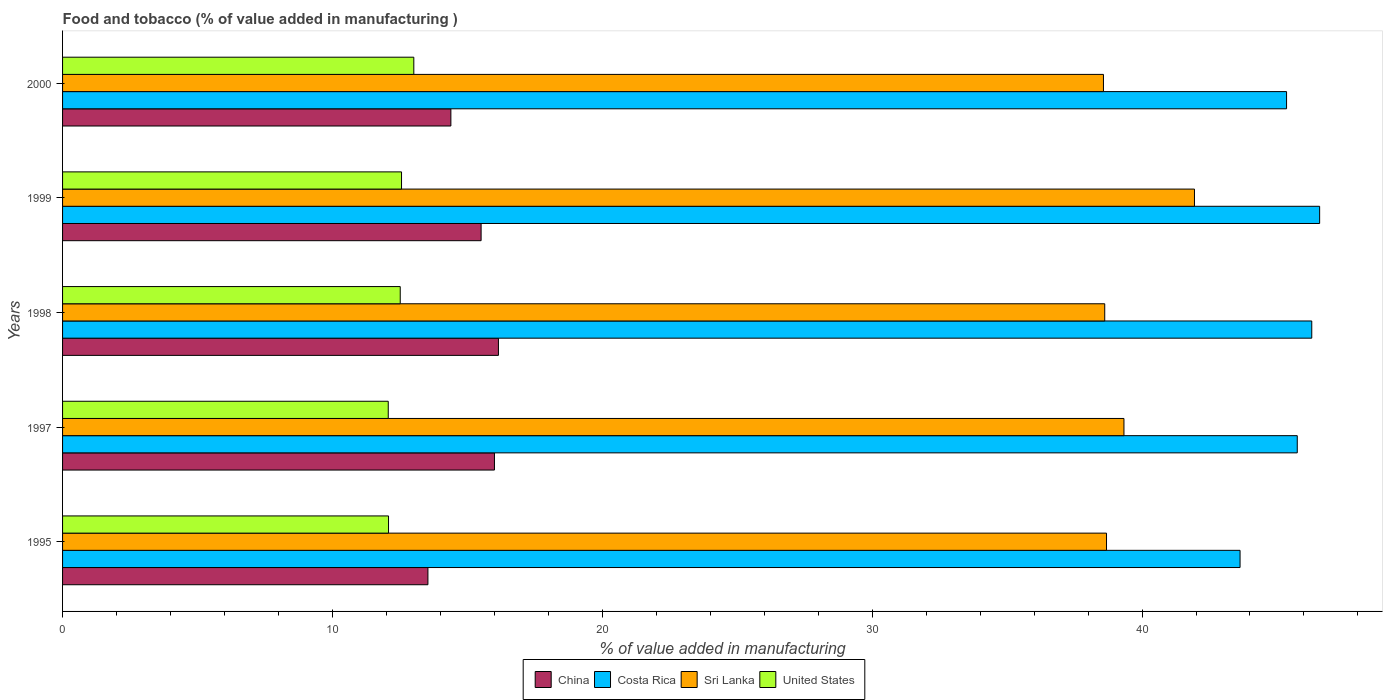How many different coloured bars are there?
Provide a short and direct response. 4. How many groups of bars are there?
Make the answer very short. 5. Are the number of bars on each tick of the Y-axis equal?
Ensure brevity in your answer.  Yes. How many bars are there on the 3rd tick from the bottom?
Offer a very short reply. 4. What is the label of the 2nd group of bars from the top?
Your response must be concise. 1999. What is the value added in manufacturing food and tobacco in Sri Lanka in 1995?
Offer a very short reply. 38.68. Across all years, what is the maximum value added in manufacturing food and tobacco in Sri Lanka?
Give a very brief answer. 41.94. Across all years, what is the minimum value added in manufacturing food and tobacco in Costa Rica?
Your answer should be compact. 43.63. In which year was the value added in manufacturing food and tobacco in Sri Lanka minimum?
Your response must be concise. 2000. What is the total value added in manufacturing food and tobacco in Sri Lanka in the graph?
Your response must be concise. 197.15. What is the difference between the value added in manufacturing food and tobacco in United States in 1998 and that in 1999?
Provide a succinct answer. -0.05. What is the difference between the value added in manufacturing food and tobacco in China in 1997 and the value added in manufacturing food and tobacco in United States in 1998?
Offer a very short reply. 3.49. What is the average value added in manufacturing food and tobacco in Sri Lanka per year?
Offer a terse response. 39.43. In the year 1999, what is the difference between the value added in manufacturing food and tobacco in Sri Lanka and value added in manufacturing food and tobacco in China?
Keep it short and to the point. 26.43. In how many years, is the value added in manufacturing food and tobacco in Costa Rica greater than 26 %?
Provide a short and direct response. 5. What is the ratio of the value added in manufacturing food and tobacco in United States in 1995 to that in 1997?
Give a very brief answer. 1. Is the value added in manufacturing food and tobacco in Costa Rica in 1995 less than that in 1997?
Provide a short and direct response. Yes. Is the difference between the value added in manufacturing food and tobacco in Sri Lanka in 1997 and 2000 greater than the difference between the value added in manufacturing food and tobacco in China in 1997 and 2000?
Give a very brief answer. No. What is the difference between the highest and the second highest value added in manufacturing food and tobacco in Sri Lanka?
Your response must be concise. 2.61. What is the difference between the highest and the lowest value added in manufacturing food and tobacco in Sri Lanka?
Offer a very short reply. 3.37. Is the sum of the value added in manufacturing food and tobacco in Costa Rica in 1995 and 1997 greater than the maximum value added in manufacturing food and tobacco in Sri Lanka across all years?
Make the answer very short. Yes. Is it the case that in every year, the sum of the value added in manufacturing food and tobacco in China and value added in manufacturing food and tobacco in Costa Rica is greater than the sum of value added in manufacturing food and tobacco in United States and value added in manufacturing food and tobacco in Sri Lanka?
Offer a terse response. Yes. What does the 4th bar from the bottom in 1998 represents?
Make the answer very short. United States. Is it the case that in every year, the sum of the value added in manufacturing food and tobacco in United States and value added in manufacturing food and tobacco in Sri Lanka is greater than the value added in manufacturing food and tobacco in Costa Rica?
Ensure brevity in your answer.  Yes. How many bars are there?
Your answer should be very brief. 20. How many years are there in the graph?
Ensure brevity in your answer.  5. What is the difference between two consecutive major ticks on the X-axis?
Provide a short and direct response. 10. Does the graph contain any zero values?
Give a very brief answer. No. Does the graph contain grids?
Make the answer very short. No. Where does the legend appear in the graph?
Ensure brevity in your answer.  Bottom center. How many legend labels are there?
Your answer should be very brief. 4. What is the title of the graph?
Keep it short and to the point. Food and tobacco (% of value added in manufacturing ). Does "Lao PDR" appear as one of the legend labels in the graph?
Your response must be concise. No. What is the label or title of the X-axis?
Your answer should be very brief. % of value added in manufacturing. What is the % of value added in manufacturing in China in 1995?
Make the answer very short. 13.54. What is the % of value added in manufacturing of Costa Rica in 1995?
Keep it short and to the point. 43.63. What is the % of value added in manufacturing in Sri Lanka in 1995?
Make the answer very short. 38.68. What is the % of value added in manufacturing of United States in 1995?
Ensure brevity in your answer.  12.08. What is the % of value added in manufacturing in China in 1997?
Your answer should be compact. 16. What is the % of value added in manufacturing in Costa Rica in 1997?
Provide a succinct answer. 45.75. What is the % of value added in manufacturing of Sri Lanka in 1997?
Your answer should be compact. 39.33. What is the % of value added in manufacturing in United States in 1997?
Ensure brevity in your answer.  12.07. What is the % of value added in manufacturing in China in 1998?
Your response must be concise. 16.15. What is the % of value added in manufacturing in Costa Rica in 1998?
Provide a short and direct response. 46.29. What is the % of value added in manufacturing of Sri Lanka in 1998?
Make the answer very short. 38.62. What is the % of value added in manufacturing in United States in 1998?
Provide a succinct answer. 12.51. What is the % of value added in manufacturing of China in 1999?
Provide a succinct answer. 15.51. What is the % of value added in manufacturing in Costa Rica in 1999?
Provide a succinct answer. 46.58. What is the % of value added in manufacturing of Sri Lanka in 1999?
Your answer should be compact. 41.94. What is the % of value added in manufacturing in United States in 1999?
Provide a succinct answer. 12.56. What is the % of value added in manufacturing of China in 2000?
Your answer should be compact. 14.39. What is the % of value added in manufacturing in Costa Rica in 2000?
Offer a very short reply. 45.36. What is the % of value added in manufacturing of Sri Lanka in 2000?
Ensure brevity in your answer.  38.57. What is the % of value added in manufacturing of United States in 2000?
Your answer should be compact. 13.02. Across all years, what is the maximum % of value added in manufacturing of China?
Your answer should be compact. 16.15. Across all years, what is the maximum % of value added in manufacturing in Costa Rica?
Make the answer very short. 46.58. Across all years, what is the maximum % of value added in manufacturing in Sri Lanka?
Your answer should be compact. 41.94. Across all years, what is the maximum % of value added in manufacturing of United States?
Your answer should be very brief. 13.02. Across all years, what is the minimum % of value added in manufacturing of China?
Offer a terse response. 13.54. Across all years, what is the minimum % of value added in manufacturing of Costa Rica?
Offer a very short reply. 43.63. Across all years, what is the minimum % of value added in manufacturing in Sri Lanka?
Your response must be concise. 38.57. Across all years, what is the minimum % of value added in manufacturing in United States?
Ensure brevity in your answer.  12.07. What is the total % of value added in manufacturing of China in the graph?
Give a very brief answer. 75.59. What is the total % of value added in manufacturing of Costa Rica in the graph?
Give a very brief answer. 227.61. What is the total % of value added in manufacturing in Sri Lanka in the graph?
Provide a succinct answer. 197.15. What is the total % of value added in manufacturing in United States in the graph?
Make the answer very short. 62.24. What is the difference between the % of value added in manufacturing in China in 1995 and that in 1997?
Keep it short and to the point. -2.47. What is the difference between the % of value added in manufacturing of Costa Rica in 1995 and that in 1997?
Offer a very short reply. -2.12. What is the difference between the % of value added in manufacturing of Sri Lanka in 1995 and that in 1997?
Give a very brief answer. -0.65. What is the difference between the % of value added in manufacturing in United States in 1995 and that in 1997?
Keep it short and to the point. 0.01. What is the difference between the % of value added in manufacturing in China in 1995 and that in 1998?
Offer a terse response. -2.61. What is the difference between the % of value added in manufacturing of Costa Rica in 1995 and that in 1998?
Give a very brief answer. -2.66. What is the difference between the % of value added in manufacturing of Sri Lanka in 1995 and that in 1998?
Ensure brevity in your answer.  0.07. What is the difference between the % of value added in manufacturing in United States in 1995 and that in 1998?
Offer a very short reply. -0.43. What is the difference between the % of value added in manufacturing of China in 1995 and that in 1999?
Give a very brief answer. -1.97. What is the difference between the % of value added in manufacturing in Costa Rica in 1995 and that in 1999?
Your answer should be very brief. -2.95. What is the difference between the % of value added in manufacturing in Sri Lanka in 1995 and that in 1999?
Keep it short and to the point. -3.26. What is the difference between the % of value added in manufacturing in United States in 1995 and that in 1999?
Keep it short and to the point. -0.48. What is the difference between the % of value added in manufacturing in China in 1995 and that in 2000?
Ensure brevity in your answer.  -0.85. What is the difference between the % of value added in manufacturing in Costa Rica in 1995 and that in 2000?
Ensure brevity in your answer.  -1.72. What is the difference between the % of value added in manufacturing of Sri Lanka in 1995 and that in 2000?
Your answer should be very brief. 0.11. What is the difference between the % of value added in manufacturing of United States in 1995 and that in 2000?
Keep it short and to the point. -0.94. What is the difference between the % of value added in manufacturing in China in 1997 and that in 1998?
Offer a terse response. -0.15. What is the difference between the % of value added in manufacturing in Costa Rica in 1997 and that in 1998?
Ensure brevity in your answer.  -0.54. What is the difference between the % of value added in manufacturing of Sri Lanka in 1997 and that in 1998?
Provide a short and direct response. 0.71. What is the difference between the % of value added in manufacturing in United States in 1997 and that in 1998?
Keep it short and to the point. -0.44. What is the difference between the % of value added in manufacturing of China in 1997 and that in 1999?
Your answer should be very brief. 0.49. What is the difference between the % of value added in manufacturing of Costa Rica in 1997 and that in 1999?
Your answer should be very brief. -0.83. What is the difference between the % of value added in manufacturing of Sri Lanka in 1997 and that in 1999?
Your response must be concise. -2.61. What is the difference between the % of value added in manufacturing of United States in 1997 and that in 1999?
Keep it short and to the point. -0.49. What is the difference between the % of value added in manufacturing of China in 1997 and that in 2000?
Give a very brief answer. 1.61. What is the difference between the % of value added in manufacturing of Costa Rica in 1997 and that in 2000?
Offer a terse response. 0.4. What is the difference between the % of value added in manufacturing of Sri Lanka in 1997 and that in 2000?
Make the answer very short. 0.76. What is the difference between the % of value added in manufacturing in United States in 1997 and that in 2000?
Your answer should be compact. -0.95. What is the difference between the % of value added in manufacturing of China in 1998 and that in 1999?
Ensure brevity in your answer.  0.64. What is the difference between the % of value added in manufacturing in Costa Rica in 1998 and that in 1999?
Your response must be concise. -0.29. What is the difference between the % of value added in manufacturing in Sri Lanka in 1998 and that in 1999?
Your answer should be very brief. -3.33. What is the difference between the % of value added in manufacturing in United States in 1998 and that in 1999?
Your answer should be very brief. -0.05. What is the difference between the % of value added in manufacturing of China in 1998 and that in 2000?
Offer a terse response. 1.76. What is the difference between the % of value added in manufacturing in Costa Rica in 1998 and that in 2000?
Your answer should be compact. 0.93. What is the difference between the % of value added in manufacturing in Sri Lanka in 1998 and that in 2000?
Give a very brief answer. 0.05. What is the difference between the % of value added in manufacturing of United States in 1998 and that in 2000?
Provide a succinct answer. -0.5. What is the difference between the % of value added in manufacturing of China in 1999 and that in 2000?
Make the answer very short. 1.12. What is the difference between the % of value added in manufacturing of Costa Rica in 1999 and that in 2000?
Your answer should be very brief. 1.23. What is the difference between the % of value added in manufacturing of Sri Lanka in 1999 and that in 2000?
Offer a terse response. 3.37. What is the difference between the % of value added in manufacturing of United States in 1999 and that in 2000?
Your answer should be compact. -0.46. What is the difference between the % of value added in manufacturing in China in 1995 and the % of value added in manufacturing in Costa Rica in 1997?
Your response must be concise. -32.21. What is the difference between the % of value added in manufacturing in China in 1995 and the % of value added in manufacturing in Sri Lanka in 1997?
Your answer should be very brief. -25.79. What is the difference between the % of value added in manufacturing in China in 1995 and the % of value added in manufacturing in United States in 1997?
Make the answer very short. 1.47. What is the difference between the % of value added in manufacturing of Costa Rica in 1995 and the % of value added in manufacturing of Sri Lanka in 1997?
Give a very brief answer. 4.3. What is the difference between the % of value added in manufacturing in Costa Rica in 1995 and the % of value added in manufacturing in United States in 1997?
Offer a very short reply. 31.56. What is the difference between the % of value added in manufacturing in Sri Lanka in 1995 and the % of value added in manufacturing in United States in 1997?
Your response must be concise. 26.62. What is the difference between the % of value added in manufacturing of China in 1995 and the % of value added in manufacturing of Costa Rica in 1998?
Provide a succinct answer. -32.75. What is the difference between the % of value added in manufacturing in China in 1995 and the % of value added in manufacturing in Sri Lanka in 1998?
Give a very brief answer. -25.08. What is the difference between the % of value added in manufacturing in Costa Rica in 1995 and the % of value added in manufacturing in Sri Lanka in 1998?
Make the answer very short. 5.01. What is the difference between the % of value added in manufacturing of Costa Rica in 1995 and the % of value added in manufacturing of United States in 1998?
Provide a succinct answer. 31.12. What is the difference between the % of value added in manufacturing of Sri Lanka in 1995 and the % of value added in manufacturing of United States in 1998?
Offer a very short reply. 26.17. What is the difference between the % of value added in manufacturing of China in 1995 and the % of value added in manufacturing of Costa Rica in 1999?
Ensure brevity in your answer.  -33.04. What is the difference between the % of value added in manufacturing in China in 1995 and the % of value added in manufacturing in Sri Lanka in 1999?
Offer a very short reply. -28.41. What is the difference between the % of value added in manufacturing in China in 1995 and the % of value added in manufacturing in United States in 1999?
Keep it short and to the point. 0.98. What is the difference between the % of value added in manufacturing in Costa Rica in 1995 and the % of value added in manufacturing in Sri Lanka in 1999?
Offer a terse response. 1.69. What is the difference between the % of value added in manufacturing in Costa Rica in 1995 and the % of value added in manufacturing in United States in 1999?
Keep it short and to the point. 31.07. What is the difference between the % of value added in manufacturing of Sri Lanka in 1995 and the % of value added in manufacturing of United States in 1999?
Your response must be concise. 26.12. What is the difference between the % of value added in manufacturing of China in 1995 and the % of value added in manufacturing of Costa Rica in 2000?
Ensure brevity in your answer.  -31.82. What is the difference between the % of value added in manufacturing in China in 1995 and the % of value added in manufacturing in Sri Lanka in 2000?
Provide a short and direct response. -25.03. What is the difference between the % of value added in manufacturing of China in 1995 and the % of value added in manufacturing of United States in 2000?
Make the answer very short. 0.52. What is the difference between the % of value added in manufacturing of Costa Rica in 1995 and the % of value added in manufacturing of Sri Lanka in 2000?
Your answer should be compact. 5.06. What is the difference between the % of value added in manufacturing in Costa Rica in 1995 and the % of value added in manufacturing in United States in 2000?
Your answer should be compact. 30.62. What is the difference between the % of value added in manufacturing in Sri Lanka in 1995 and the % of value added in manufacturing in United States in 2000?
Give a very brief answer. 25.67. What is the difference between the % of value added in manufacturing of China in 1997 and the % of value added in manufacturing of Costa Rica in 1998?
Ensure brevity in your answer.  -30.29. What is the difference between the % of value added in manufacturing of China in 1997 and the % of value added in manufacturing of Sri Lanka in 1998?
Give a very brief answer. -22.61. What is the difference between the % of value added in manufacturing in China in 1997 and the % of value added in manufacturing in United States in 1998?
Your answer should be compact. 3.49. What is the difference between the % of value added in manufacturing in Costa Rica in 1997 and the % of value added in manufacturing in Sri Lanka in 1998?
Your response must be concise. 7.13. What is the difference between the % of value added in manufacturing of Costa Rica in 1997 and the % of value added in manufacturing of United States in 1998?
Provide a short and direct response. 33.24. What is the difference between the % of value added in manufacturing of Sri Lanka in 1997 and the % of value added in manufacturing of United States in 1998?
Give a very brief answer. 26.82. What is the difference between the % of value added in manufacturing in China in 1997 and the % of value added in manufacturing in Costa Rica in 1999?
Provide a short and direct response. -30.58. What is the difference between the % of value added in manufacturing of China in 1997 and the % of value added in manufacturing of Sri Lanka in 1999?
Provide a short and direct response. -25.94. What is the difference between the % of value added in manufacturing of China in 1997 and the % of value added in manufacturing of United States in 1999?
Make the answer very short. 3.44. What is the difference between the % of value added in manufacturing of Costa Rica in 1997 and the % of value added in manufacturing of Sri Lanka in 1999?
Ensure brevity in your answer.  3.81. What is the difference between the % of value added in manufacturing in Costa Rica in 1997 and the % of value added in manufacturing in United States in 1999?
Give a very brief answer. 33.19. What is the difference between the % of value added in manufacturing of Sri Lanka in 1997 and the % of value added in manufacturing of United States in 1999?
Give a very brief answer. 26.77. What is the difference between the % of value added in manufacturing of China in 1997 and the % of value added in manufacturing of Costa Rica in 2000?
Provide a short and direct response. -29.35. What is the difference between the % of value added in manufacturing of China in 1997 and the % of value added in manufacturing of Sri Lanka in 2000?
Offer a very short reply. -22.57. What is the difference between the % of value added in manufacturing in China in 1997 and the % of value added in manufacturing in United States in 2000?
Provide a succinct answer. 2.99. What is the difference between the % of value added in manufacturing of Costa Rica in 1997 and the % of value added in manufacturing of Sri Lanka in 2000?
Ensure brevity in your answer.  7.18. What is the difference between the % of value added in manufacturing in Costa Rica in 1997 and the % of value added in manufacturing in United States in 2000?
Provide a short and direct response. 32.74. What is the difference between the % of value added in manufacturing of Sri Lanka in 1997 and the % of value added in manufacturing of United States in 2000?
Give a very brief answer. 26.31. What is the difference between the % of value added in manufacturing of China in 1998 and the % of value added in manufacturing of Costa Rica in 1999?
Offer a terse response. -30.43. What is the difference between the % of value added in manufacturing of China in 1998 and the % of value added in manufacturing of Sri Lanka in 1999?
Your answer should be very brief. -25.79. What is the difference between the % of value added in manufacturing of China in 1998 and the % of value added in manufacturing of United States in 1999?
Provide a succinct answer. 3.59. What is the difference between the % of value added in manufacturing in Costa Rica in 1998 and the % of value added in manufacturing in Sri Lanka in 1999?
Provide a short and direct response. 4.35. What is the difference between the % of value added in manufacturing in Costa Rica in 1998 and the % of value added in manufacturing in United States in 1999?
Provide a short and direct response. 33.73. What is the difference between the % of value added in manufacturing of Sri Lanka in 1998 and the % of value added in manufacturing of United States in 1999?
Give a very brief answer. 26.06. What is the difference between the % of value added in manufacturing of China in 1998 and the % of value added in manufacturing of Costa Rica in 2000?
Give a very brief answer. -29.2. What is the difference between the % of value added in manufacturing of China in 1998 and the % of value added in manufacturing of Sri Lanka in 2000?
Your answer should be compact. -22.42. What is the difference between the % of value added in manufacturing of China in 1998 and the % of value added in manufacturing of United States in 2000?
Offer a very short reply. 3.14. What is the difference between the % of value added in manufacturing in Costa Rica in 1998 and the % of value added in manufacturing in Sri Lanka in 2000?
Offer a very short reply. 7.72. What is the difference between the % of value added in manufacturing in Costa Rica in 1998 and the % of value added in manufacturing in United States in 2000?
Make the answer very short. 33.27. What is the difference between the % of value added in manufacturing in Sri Lanka in 1998 and the % of value added in manufacturing in United States in 2000?
Offer a very short reply. 25.6. What is the difference between the % of value added in manufacturing in China in 1999 and the % of value added in manufacturing in Costa Rica in 2000?
Provide a short and direct response. -29.85. What is the difference between the % of value added in manufacturing of China in 1999 and the % of value added in manufacturing of Sri Lanka in 2000?
Make the answer very short. -23.06. What is the difference between the % of value added in manufacturing in China in 1999 and the % of value added in manufacturing in United States in 2000?
Provide a succinct answer. 2.49. What is the difference between the % of value added in manufacturing in Costa Rica in 1999 and the % of value added in manufacturing in Sri Lanka in 2000?
Keep it short and to the point. 8.01. What is the difference between the % of value added in manufacturing of Costa Rica in 1999 and the % of value added in manufacturing of United States in 2000?
Ensure brevity in your answer.  33.57. What is the difference between the % of value added in manufacturing in Sri Lanka in 1999 and the % of value added in manufacturing in United States in 2000?
Make the answer very short. 28.93. What is the average % of value added in manufacturing of China per year?
Give a very brief answer. 15.12. What is the average % of value added in manufacturing in Costa Rica per year?
Offer a terse response. 45.52. What is the average % of value added in manufacturing in Sri Lanka per year?
Provide a short and direct response. 39.43. What is the average % of value added in manufacturing of United States per year?
Your response must be concise. 12.45. In the year 1995, what is the difference between the % of value added in manufacturing in China and % of value added in manufacturing in Costa Rica?
Offer a very short reply. -30.09. In the year 1995, what is the difference between the % of value added in manufacturing of China and % of value added in manufacturing of Sri Lanka?
Ensure brevity in your answer.  -25.15. In the year 1995, what is the difference between the % of value added in manufacturing of China and % of value added in manufacturing of United States?
Provide a short and direct response. 1.46. In the year 1995, what is the difference between the % of value added in manufacturing of Costa Rica and % of value added in manufacturing of Sri Lanka?
Offer a terse response. 4.95. In the year 1995, what is the difference between the % of value added in manufacturing in Costa Rica and % of value added in manufacturing in United States?
Your answer should be compact. 31.55. In the year 1995, what is the difference between the % of value added in manufacturing in Sri Lanka and % of value added in manufacturing in United States?
Make the answer very short. 26.61. In the year 1997, what is the difference between the % of value added in manufacturing in China and % of value added in manufacturing in Costa Rica?
Provide a succinct answer. -29.75. In the year 1997, what is the difference between the % of value added in manufacturing of China and % of value added in manufacturing of Sri Lanka?
Provide a short and direct response. -23.33. In the year 1997, what is the difference between the % of value added in manufacturing of China and % of value added in manufacturing of United States?
Provide a succinct answer. 3.94. In the year 1997, what is the difference between the % of value added in manufacturing of Costa Rica and % of value added in manufacturing of Sri Lanka?
Your response must be concise. 6.42. In the year 1997, what is the difference between the % of value added in manufacturing of Costa Rica and % of value added in manufacturing of United States?
Your answer should be very brief. 33.68. In the year 1997, what is the difference between the % of value added in manufacturing of Sri Lanka and % of value added in manufacturing of United States?
Your answer should be compact. 27.26. In the year 1998, what is the difference between the % of value added in manufacturing of China and % of value added in manufacturing of Costa Rica?
Your answer should be very brief. -30.14. In the year 1998, what is the difference between the % of value added in manufacturing in China and % of value added in manufacturing in Sri Lanka?
Your answer should be very brief. -22.47. In the year 1998, what is the difference between the % of value added in manufacturing in China and % of value added in manufacturing in United States?
Your answer should be compact. 3.64. In the year 1998, what is the difference between the % of value added in manufacturing in Costa Rica and % of value added in manufacturing in Sri Lanka?
Provide a short and direct response. 7.67. In the year 1998, what is the difference between the % of value added in manufacturing of Costa Rica and % of value added in manufacturing of United States?
Your answer should be very brief. 33.78. In the year 1998, what is the difference between the % of value added in manufacturing of Sri Lanka and % of value added in manufacturing of United States?
Make the answer very short. 26.11. In the year 1999, what is the difference between the % of value added in manufacturing in China and % of value added in manufacturing in Costa Rica?
Your answer should be compact. -31.07. In the year 1999, what is the difference between the % of value added in manufacturing of China and % of value added in manufacturing of Sri Lanka?
Provide a short and direct response. -26.43. In the year 1999, what is the difference between the % of value added in manufacturing of China and % of value added in manufacturing of United States?
Give a very brief answer. 2.95. In the year 1999, what is the difference between the % of value added in manufacturing in Costa Rica and % of value added in manufacturing in Sri Lanka?
Your answer should be very brief. 4.64. In the year 1999, what is the difference between the % of value added in manufacturing in Costa Rica and % of value added in manufacturing in United States?
Give a very brief answer. 34.02. In the year 1999, what is the difference between the % of value added in manufacturing in Sri Lanka and % of value added in manufacturing in United States?
Your response must be concise. 29.38. In the year 2000, what is the difference between the % of value added in manufacturing in China and % of value added in manufacturing in Costa Rica?
Your response must be concise. -30.97. In the year 2000, what is the difference between the % of value added in manufacturing of China and % of value added in manufacturing of Sri Lanka?
Ensure brevity in your answer.  -24.18. In the year 2000, what is the difference between the % of value added in manufacturing in China and % of value added in manufacturing in United States?
Ensure brevity in your answer.  1.37. In the year 2000, what is the difference between the % of value added in manufacturing of Costa Rica and % of value added in manufacturing of Sri Lanka?
Your answer should be very brief. 6.79. In the year 2000, what is the difference between the % of value added in manufacturing in Costa Rica and % of value added in manufacturing in United States?
Your response must be concise. 32.34. In the year 2000, what is the difference between the % of value added in manufacturing of Sri Lanka and % of value added in manufacturing of United States?
Ensure brevity in your answer.  25.56. What is the ratio of the % of value added in manufacturing of China in 1995 to that in 1997?
Provide a succinct answer. 0.85. What is the ratio of the % of value added in manufacturing in Costa Rica in 1995 to that in 1997?
Give a very brief answer. 0.95. What is the ratio of the % of value added in manufacturing in Sri Lanka in 1995 to that in 1997?
Make the answer very short. 0.98. What is the ratio of the % of value added in manufacturing of China in 1995 to that in 1998?
Your answer should be very brief. 0.84. What is the ratio of the % of value added in manufacturing in Costa Rica in 1995 to that in 1998?
Ensure brevity in your answer.  0.94. What is the ratio of the % of value added in manufacturing of United States in 1995 to that in 1998?
Make the answer very short. 0.97. What is the ratio of the % of value added in manufacturing of China in 1995 to that in 1999?
Give a very brief answer. 0.87. What is the ratio of the % of value added in manufacturing in Costa Rica in 1995 to that in 1999?
Offer a very short reply. 0.94. What is the ratio of the % of value added in manufacturing of Sri Lanka in 1995 to that in 1999?
Offer a terse response. 0.92. What is the ratio of the % of value added in manufacturing in United States in 1995 to that in 1999?
Provide a short and direct response. 0.96. What is the ratio of the % of value added in manufacturing in China in 1995 to that in 2000?
Offer a very short reply. 0.94. What is the ratio of the % of value added in manufacturing of Sri Lanka in 1995 to that in 2000?
Your answer should be very brief. 1. What is the ratio of the % of value added in manufacturing of United States in 1995 to that in 2000?
Keep it short and to the point. 0.93. What is the ratio of the % of value added in manufacturing in Costa Rica in 1997 to that in 1998?
Keep it short and to the point. 0.99. What is the ratio of the % of value added in manufacturing in Sri Lanka in 1997 to that in 1998?
Provide a short and direct response. 1.02. What is the ratio of the % of value added in manufacturing in United States in 1997 to that in 1998?
Your answer should be compact. 0.96. What is the ratio of the % of value added in manufacturing in China in 1997 to that in 1999?
Your answer should be very brief. 1.03. What is the ratio of the % of value added in manufacturing of Costa Rica in 1997 to that in 1999?
Provide a succinct answer. 0.98. What is the ratio of the % of value added in manufacturing of Sri Lanka in 1997 to that in 1999?
Your response must be concise. 0.94. What is the ratio of the % of value added in manufacturing of United States in 1997 to that in 1999?
Ensure brevity in your answer.  0.96. What is the ratio of the % of value added in manufacturing of China in 1997 to that in 2000?
Your response must be concise. 1.11. What is the ratio of the % of value added in manufacturing of Costa Rica in 1997 to that in 2000?
Provide a short and direct response. 1.01. What is the ratio of the % of value added in manufacturing in Sri Lanka in 1997 to that in 2000?
Provide a succinct answer. 1.02. What is the ratio of the % of value added in manufacturing of United States in 1997 to that in 2000?
Provide a short and direct response. 0.93. What is the ratio of the % of value added in manufacturing of China in 1998 to that in 1999?
Provide a short and direct response. 1.04. What is the ratio of the % of value added in manufacturing in Costa Rica in 1998 to that in 1999?
Your answer should be very brief. 0.99. What is the ratio of the % of value added in manufacturing of Sri Lanka in 1998 to that in 1999?
Keep it short and to the point. 0.92. What is the ratio of the % of value added in manufacturing in United States in 1998 to that in 1999?
Offer a terse response. 1. What is the ratio of the % of value added in manufacturing in China in 1998 to that in 2000?
Offer a very short reply. 1.12. What is the ratio of the % of value added in manufacturing in Costa Rica in 1998 to that in 2000?
Offer a terse response. 1.02. What is the ratio of the % of value added in manufacturing of Sri Lanka in 1998 to that in 2000?
Your response must be concise. 1. What is the ratio of the % of value added in manufacturing in United States in 1998 to that in 2000?
Provide a short and direct response. 0.96. What is the ratio of the % of value added in manufacturing of China in 1999 to that in 2000?
Your response must be concise. 1.08. What is the ratio of the % of value added in manufacturing of Sri Lanka in 1999 to that in 2000?
Make the answer very short. 1.09. What is the ratio of the % of value added in manufacturing in United States in 1999 to that in 2000?
Offer a terse response. 0.96. What is the difference between the highest and the second highest % of value added in manufacturing in China?
Your answer should be compact. 0.15. What is the difference between the highest and the second highest % of value added in manufacturing of Costa Rica?
Your answer should be very brief. 0.29. What is the difference between the highest and the second highest % of value added in manufacturing of Sri Lanka?
Keep it short and to the point. 2.61. What is the difference between the highest and the second highest % of value added in manufacturing of United States?
Give a very brief answer. 0.46. What is the difference between the highest and the lowest % of value added in manufacturing of China?
Your answer should be compact. 2.61. What is the difference between the highest and the lowest % of value added in manufacturing of Costa Rica?
Make the answer very short. 2.95. What is the difference between the highest and the lowest % of value added in manufacturing of Sri Lanka?
Provide a succinct answer. 3.37. What is the difference between the highest and the lowest % of value added in manufacturing of United States?
Provide a succinct answer. 0.95. 